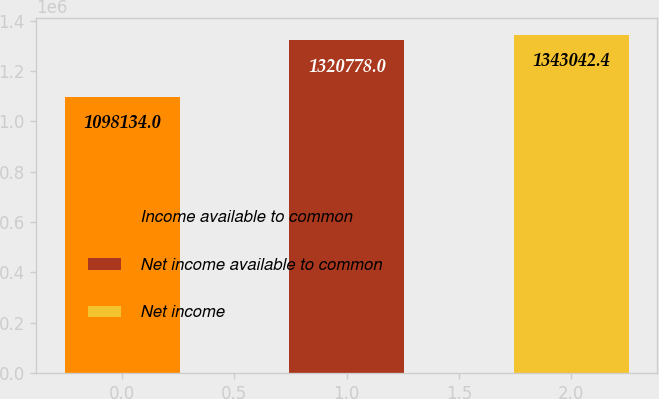<chart> <loc_0><loc_0><loc_500><loc_500><bar_chart><fcel>Income available to common<fcel>Net income available to common<fcel>Net income<nl><fcel>1.09813e+06<fcel>1.32078e+06<fcel>1.34304e+06<nl></chart> 